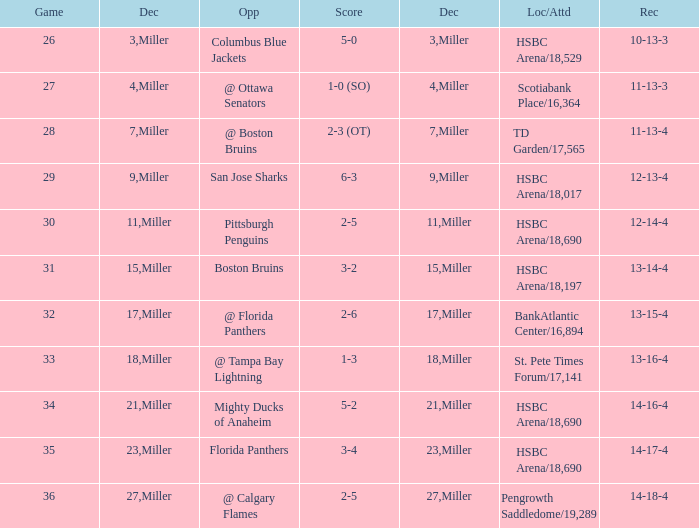Name the december for record 14-17-4 23.0. 